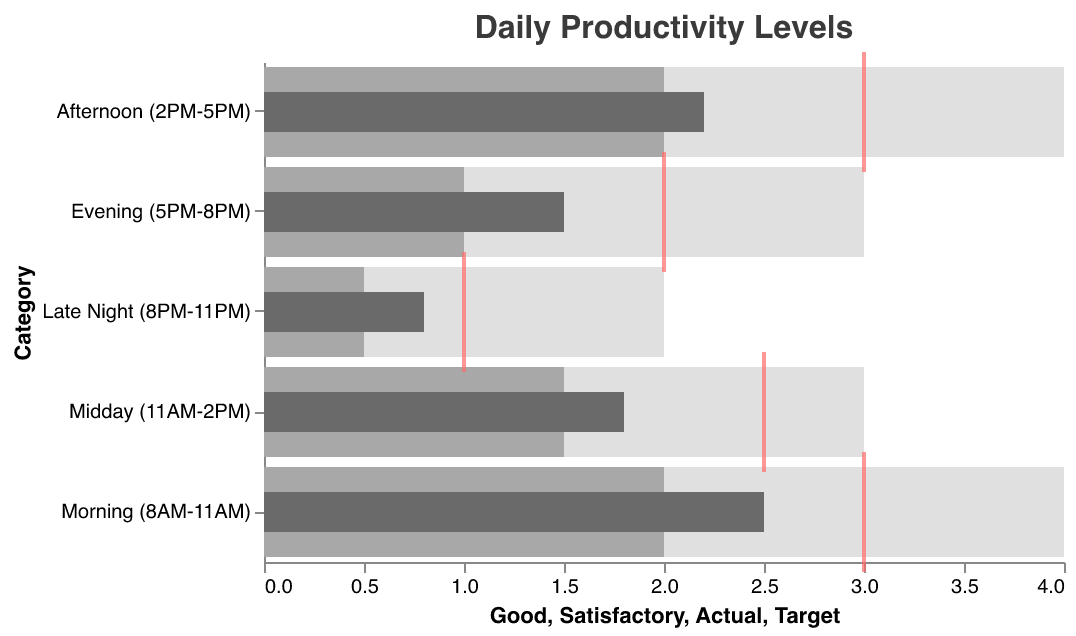What's the overall title of the chart? The title is displayed at the top of the chart and reads "Daily Productivity Levels".
Answer: Daily Productivity Levels In which time period is the productivity level closest to the target? By comparing the "Actual" and "Target" values, we see that the "Morning (8AM-11AM)" period has an Actual value of 2.5 and a Target value of 3, the smallest difference among all periods.
Answer: Morning (8AM-11AM) Which time period has the lowest productivity level? The "Actual" column provides information on productivity levels. "Late Night (8PM-11PM)" has the lowest value at 0.8.
Answer: Late Night (8PM-11PM) During which time period is the satisfactory range the widest? To determine this, compare the difference between the "Satisfactory" and "Poor" values. The "Morning (8AM-11AM)" has a difference of 2 (2 - 0), which is the widest.
Answer: Morning (8AM-11AM) How does the actual productivity level for the Afternoon compare with its target? For the Afternoon (2PM-5PM), the Actual value is 2.2 and the Target value is 3. The Actual value is 0.8 less than the Target.
Answer: 0.8 less Which time period shows actual productivity in the "Poor" range? The Poor range goes up to 2 for most periods. The Evening (5PM-8PM) has an Actual productivity of 1.5, which falls within "Poor".
Answer: Evening (5PM-8PM) Is any time period’s actual productivity level equal to the target level? By checking each period's "Actual" and "Target" values, none of the Actual productivity levels match their respective Target values exactly.
Answer: No What is the difference between the morning and late night actual productivity levels? The "Actual" value for Morning (8AM-11AM) is 2.5, and for Late Night (8PM-11PM) is 0.8. The difference is 2.5 - 0.8 = 1.7.
Answer: 1.7 Which time periods meet or exceed the satisfactory level? By comparing "Actual" to "Satisfactory," we see that the Morning (8AM-11AM) and the Afternoon (2PM-5PM) have actual values greater than or equal to their satisfactory levels of 2 and 2.2, respectively.
Answer: Morning (8AM-11AM), Afternoon (2PM-5PM) Which time period has the smallest range between satisfactory and good levels? The smallest difference between "Good" and "Satisfactory" values is in the Late Night (8PM-11PM) period, with a difference of 2 - 0.5 = 1.5.
Answer: Late Night (8PM-11PM) 